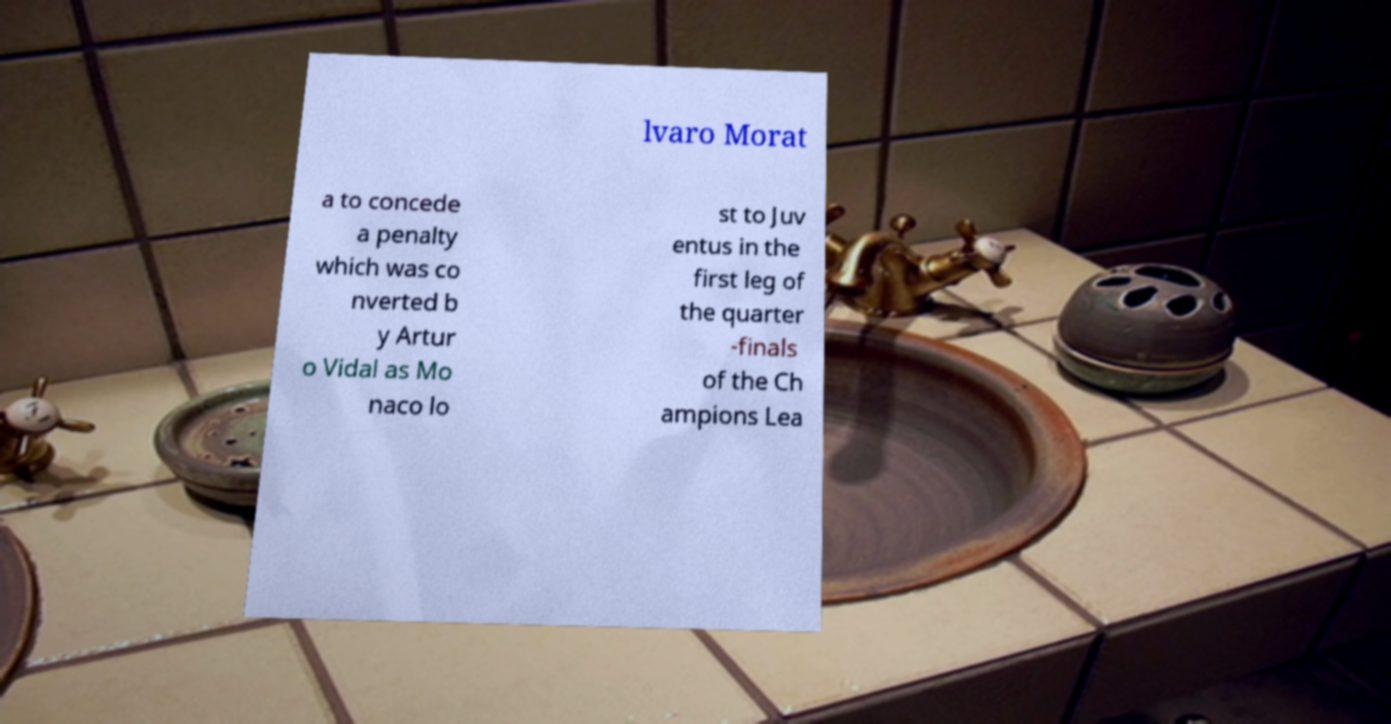Please read and relay the text visible in this image. What does it say? lvaro Morat a to concede a penalty which was co nverted b y Artur o Vidal as Mo naco lo st to Juv entus in the first leg of the quarter -finals of the Ch ampions Lea 